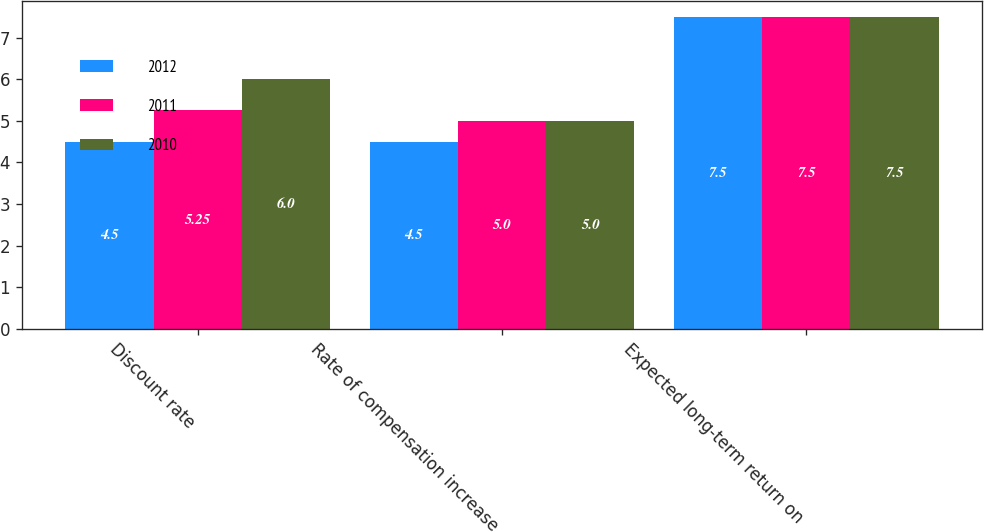Convert chart to OTSL. <chart><loc_0><loc_0><loc_500><loc_500><stacked_bar_chart><ecel><fcel>Discount rate<fcel>Rate of compensation increase<fcel>Expected long-term return on<nl><fcel>2012<fcel>4.5<fcel>4.5<fcel>7.5<nl><fcel>2011<fcel>5.25<fcel>5<fcel>7.5<nl><fcel>2010<fcel>6<fcel>5<fcel>7.5<nl></chart> 